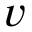Convert formula to latex. <formula><loc_0><loc_0><loc_500><loc_500>v</formula> 